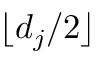Convert formula to latex. <formula><loc_0><loc_0><loc_500><loc_500>\lfloor d _ { j } / 2 \rfloor</formula> 